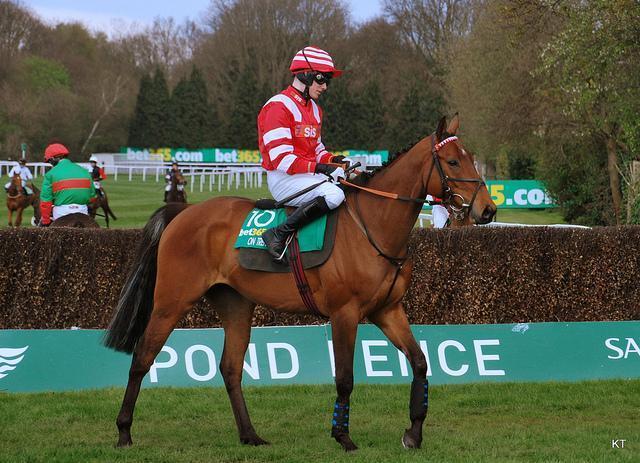How many people are there?
Give a very brief answer. 2. How many televisions are on the left of the door?
Give a very brief answer. 0. 